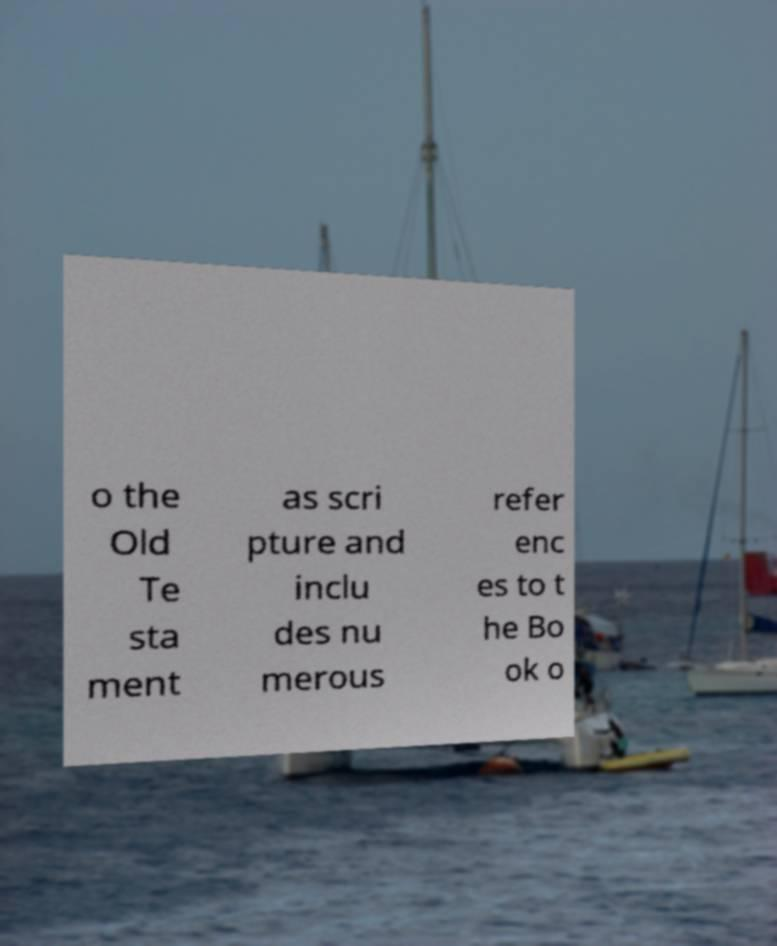There's text embedded in this image that I need extracted. Can you transcribe it verbatim? o the Old Te sta ment as scri pture and inclu des nu merous refer enc es to t he Bo ok o 